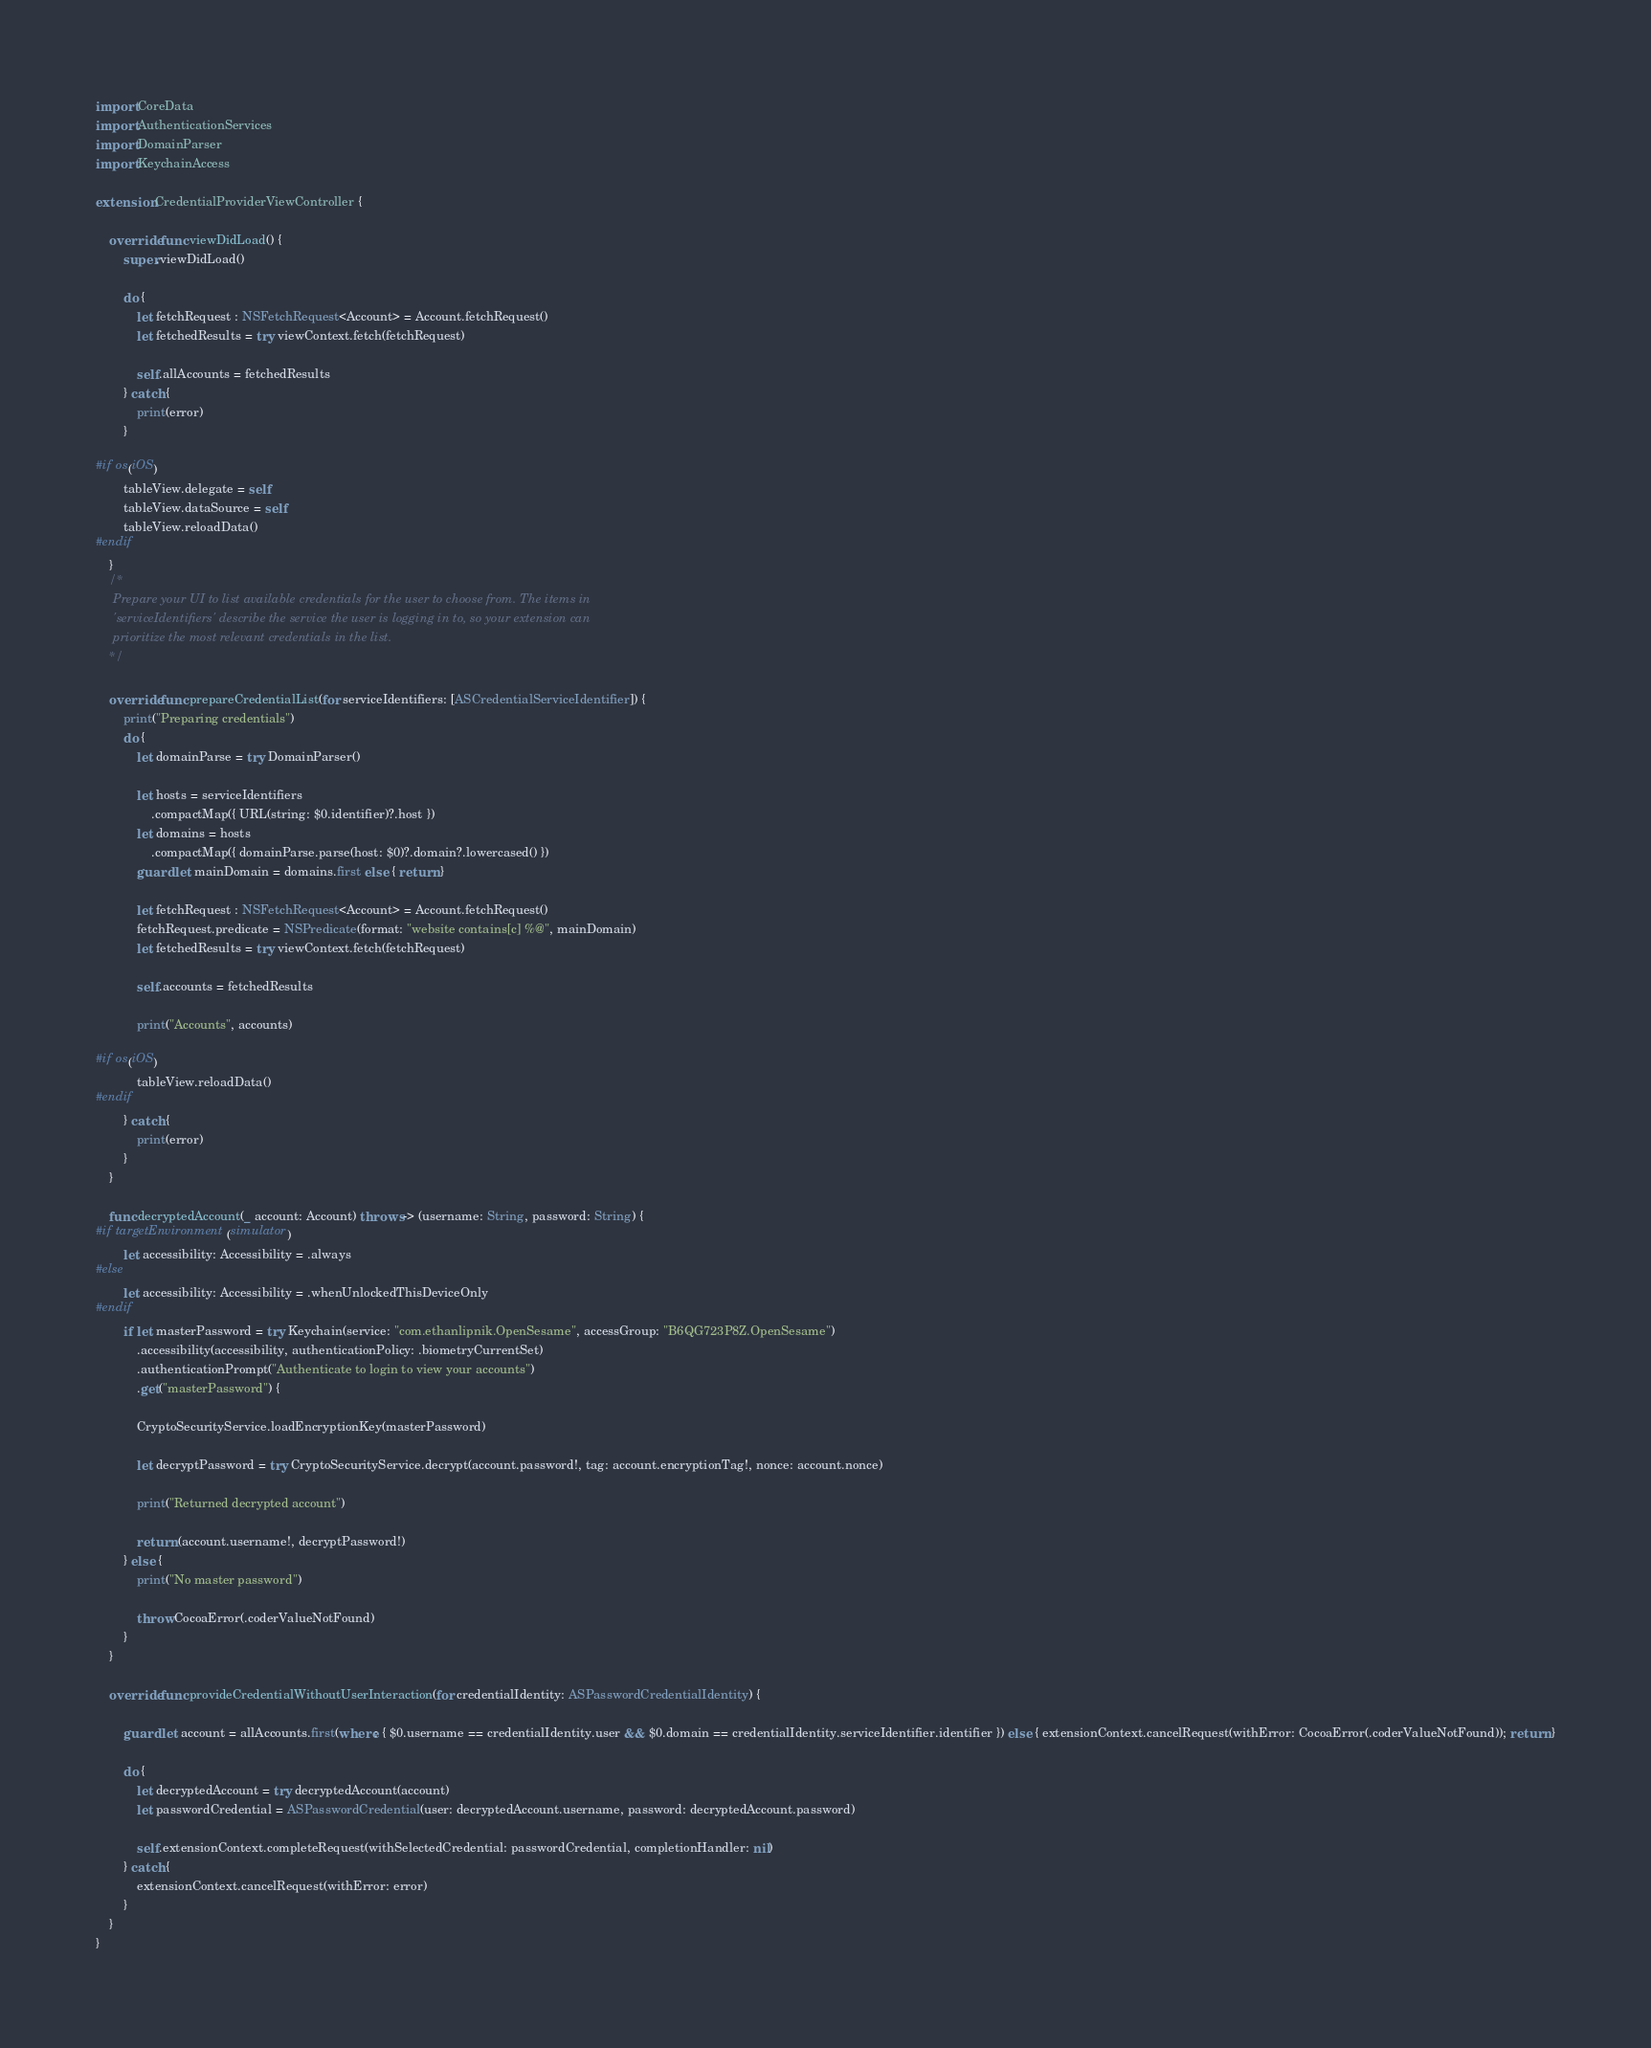Convert code to text. <code><loc_0><loc_0><loc_500><loc_500><_Swift_>import CoreData
import AuthenticationServices
import DomainParser
import KeychainAccess

extension CredentialProviderViewController {
    
    override func viewDidLoad() {
        super.viewDidLoad()
        
        do {
            let fetchRequest : NSFetchRequest<Account> = Account.fetchRequest()
            let fetchedResults = try viewContext.fetch(fetchRequest)
            
            self.allAccounts = fetchedResults
        } catch {
            print(error)
        }
        
#if os(iOS)
        tableView.delegate = self
        tableView.dataSource = self
        tableView.reloadData()
#endif
    }
    /*
     Prepare your UI to list available credentials for the user to choose from. The items in
     'serviceIdentifiers' describe the service the user is logging in to, so your extension can
     prioritize the most relevant credentials in the list.
    */
    
    override func prepareCredentialList(for serviceIdentifiers: [ASCredentialServiceIdentifier]) {
        print("Preparing credentials")
        do {
            let domainParse = try DomainParser()
            
            let hosts = serviceIdentifiers
                .compactMap({ URL(string: $0.identifier)?.host })
            let domains = hosts
                .compactMap({ domainParse.parse(host: $0)?.domain?.lowercased() })
            guard let mainDomain = domains.first else { return }
            
            let fetchRequest : NSFetchRequest<Account> = Account.fetchRequest()
            fetchRequest.predicate = NSPredicate(format: "website contains[c] %@", mainDomain)
            let fetchedResults = try viewContext.fetch(fetchRequest)
            
            self.accounts = fetchedResults
            
            print("Accounts", accounts)
            
#if os(iOS)
            tableView.reloadData()
#endif
        } catch {
            print(error)
        }
    }
    
    func decryptedAccount(_ account: Account) throws -> (username: String, password: String) {
#if targetEnvironment(simulator)
        let accessibility: Accessibility = .always
#else
        let accessibility: Accessibility = .whenUnlockedThisDeviceOnly
#endif
        if let masterPassword = try Keychain(service: "com.ethanlipnik.OpenSesame", accessGroup: "B6QG723P8Z.OpenSesame")
            .accessibility(accessibility, authenticationPolicy: .biometryCurrentSet)
            .authenticationPrompt("Authenticate to login to view your accounts")
            .get("masterPassword") {
            
            CryptoSecurityService.loadEncryptionKey(masterPassword)
            
            let decryptPassword = try CryptoSecurityService.decrypt(account.password!, tag: account.encryptionTag!, nonce: account.nonce)
            
            print("Returned decrypted account")
            
            return (account.username!, decryptPassword!)
        } else {
            print("No master password")
            
            throw CocoaError(.coderValueNotFound)
        }
    }
    
    override func provideCredentialWithoutUserInteraction(for credentialIdentity: ASPasswordCredentialIdentity) {
        
        guard let account = allAccounts.first(where: { $0.username == credentialIdentity.user && $0.domain == credentialIdentity.serviceIdentifier.identifier }) else { extensionContext.cancelRequest(withError: CocoaError(.coderValueNotFound)); return }
        
        do {
            let decryptedAccount = try decryptedAccount(account)
            let passwordCredential = ASPasswordCredential(user: decryptedAccount.username, password: decryptedAccount.password)
            
            self.extensionContext.completeRequest(withSelectedCredential: passwordCredential, completionHandler: nil)
        } catch {
            extensionContext.cancelRequest(withError: error)
        }
    }
}
</code> 